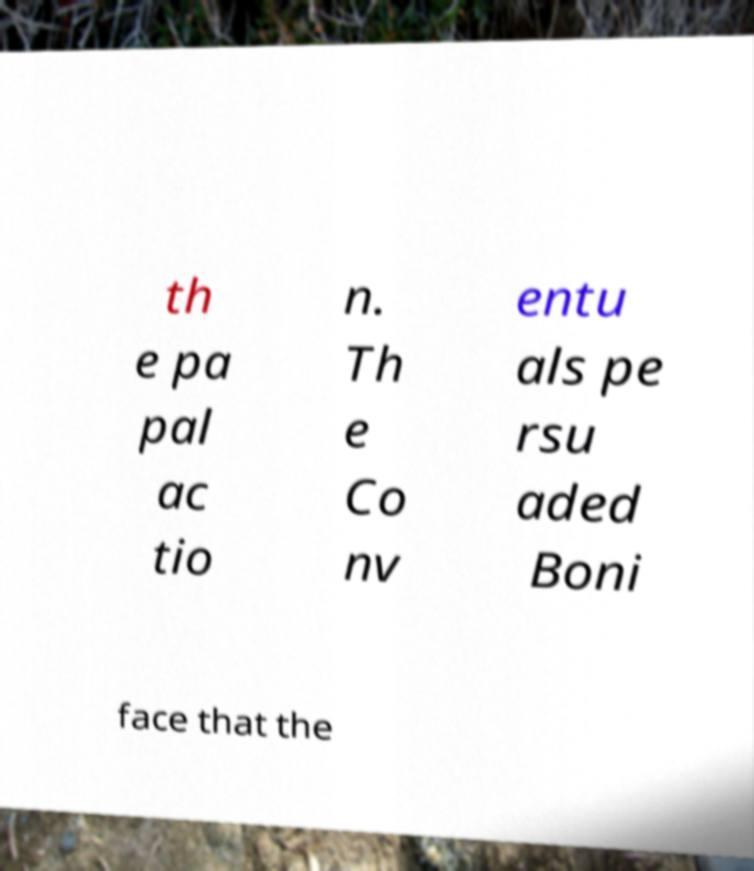Could you assist in decoding the text presented in this image and type it out clearly? th e pa pal ac tio n. Th e Co nv entu als pe rsu aded Boni face that the 